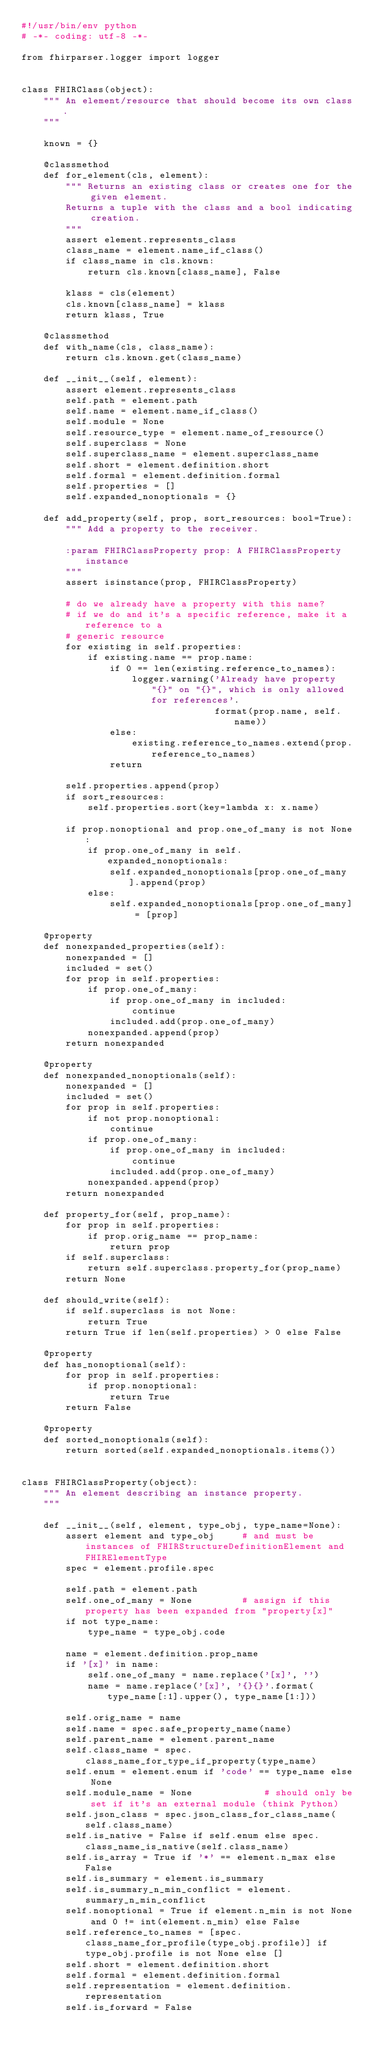<code> <loc_0><loc_0><loc_500><loc_500><_Python_>#!/usr/bin/env python
# -*- coding: utf-8 -*-

from fhirparser.logger import logger


class FHIRClass(object):
    """ An element/resource that should become its own class.
    """
    
    known = {}
    
    @classmethod
    def for_element(cls, element):
        """ Returns an existing class or creates one for the given element.
        Returns a tuple with the class and a bool indicating creation.
        """
        assert element.represents_class
        class_name = element.name_if_class()
        if class_name in cls.known:
            return cls.known[class_name], False
        
        klass = cls(element)
        cls.known[class_name] = klass
        return klass, True
    
    @classmethod
    def with_name(cls, class_name):
        return cls.known.get(class_name)
    
    def __init__(self, element):
        assert element.represents_class
        self.path = element.path
        self.name = element.name_if_class()
        self.module = None
        self.resource_type = element.name_of_resource()
        self.superclass = None
        self.superclass_name = element.superclass_name
        self.short = element.definition.short
        self.formal = element.definition.formal
        self.properties = []
        self.expanded_nonoptionals = {}
    
    def add_property(self, prop, sort_resources: bool=True):
        """ Add a property to the receiver.
        
        :param FHIRClassProperty prop: A FHIRClassProperty instance
        """
        assert isinstance(prop, FHIRClassProperty)
        
        # do we already have a property with this name?
        # if we do and it's a specific reference, make it a reference to a
        # generic resource
        for existing in self.properties:
            if existing.name == prop.name:
                if 0 == len(existing.reference_to_names):
                    logger.warning('Already have property "{}" on "{}", which is only allowed for references'.
                                   format(prop.name, self.name))
                else:
                    existing.reference_to_names.extend(prop.reference_to_names)
                return
        
        self.properties.append(prop)
        if sort_resources:
            self.properties.sort(key=lambda x: x.name)
        
        if prop.nonoptional and prop.one_of_many is not None:
            if prop.one_of_many in self.expanded_nonoptionals:
                self.expanded_nonoptionals[prop.one_of_many].append(prop)
            else:
                self.expanded_nonoptionals[prop.one_of_many] = [prop]
    
    @property
    def nonexpanded_properties(self):
        nonexpanded = []
        included = set()
        for prop in self.properties:
            if prop.one_of_many:
                if prop.one_of_many in included:
                    continue
                included.add(prop.one_of_many)
            nonexpanded.append(prop)
        return nonexpanded
    
    @property
    def nonexpanded_nonoptionals(self):
        nonexpanded = []
        included = set()
        for prop in self.properties:
            if not prop.nonoptional:
                continue
            if prop.one_of_many:
                if prop.one_of_many in included:
                    continue
                included.add(prop.one_of_many)
            nonexpanded.append(prop)
        return nonexpanded
    
    def property_for(self, prop_name):
        for prop in self.properties:
            if prop.orig_name == prop_name:
                return prop
        if self.superclass:
            return self.superclass.property_for(prop_name)
        return None
    
    def should_write(self):
        if self.superclass is not None:
            return True
        return True if len(self.properties) > 0 else False
    
    @property
    def has_nonoptional(self):
        for prop in self.properties:
            if prop.nonoptional:
                return True
        return False
    
    @property
    def sorted_nonoptionals(self):
        return sorted(self.expanded_nonoptionals.items())


class FHIRClassProperty(object):
    """ An element describing an instance property.
    """
    
    def __init__(self, element, type_obj, type_name=None):
        assert element and type_obj     # and must be instances of FHIRStructureDefinitionElement and FHIRElementType
        spec = element.profile.spec
        
        self.path = element.path
        self.one_of_many = None         # assign if this property has been expanded from "property[x]"
        if not type_name:
            type_name = type_obj.code
        
        name = element.definition.prop_name
        if '[x]' in name:
            self.one_of_many = name.replace('[x]', '')
            name = name.replace('[x]', '{}{}'.format(type_name[:1].upper(), type_name[1:]))
        
        self.orig_name = name
        self.name = spec.safe_property_name(name)
        self.parent_name = element.parent_name
        self.class_name = spec.class_name_for_type_if_property(type_name)
        self.enum = element.enum if 'code' == type_name else None
        self.module_name = None             # should only be set if it's an external module (think Python)
        self.json_class = spec.json_class_for_class_name(self.class_name)
        self.is_native = False if self.enum else spec.class_name_is_native(self.class_name)
        self.is_array = True if '*' == element.n_max else False
        self.is_summary = element.is_summary
        self.is_summary_n_min_conflict = element.summary_n_min_conflict
        self.nonoptional = True if element.n_min is not None and 0 != int(element.n_min) else False
        self.reference_to_names = [spec.class_name_for_profile(type_obj.profile)] if type_obj.profile is not None else []
        self.short = element.definition.short
        self.formal = element.definition.formal
        self.representation = element.definition.representation
        self.is_forward = False

</code> 